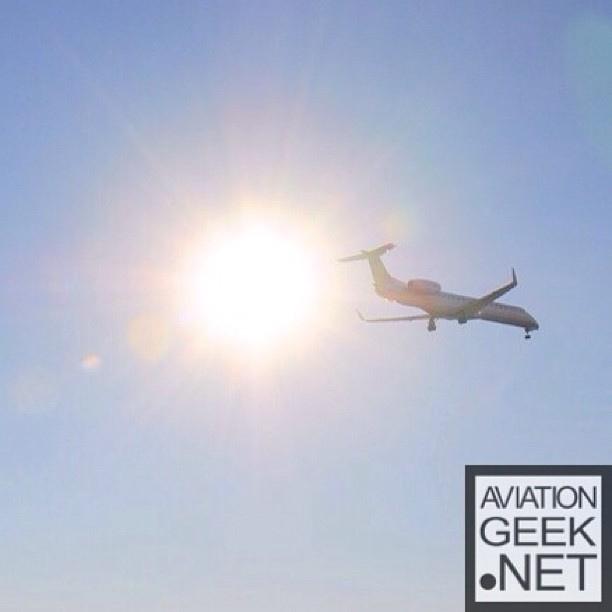Was this picture likely to have been taken at noon?
Answer briefly. Yes. What is the writing in picture?
Concise answer only. Aviation geek net. What is in the sky behind the airplane?
Short answer required. Sun. Is the sky overcast?
Short answer required. No. What is trailing from the plane?
Quick response, please. Sun. Hazy or sunny?
Keep it brief. Sunny. Could this plane be military?
Answer briefly. No. Is there a lake in the picture?
Be succinct. No. Are there clouds?
Answer briefly. No. What is shining so brightly?
Concise answer only. Sun. Is it night time?
Be succinct. No. What is in the air?
Quick response, please. Airplane. What time of day is it?
Short answer required. Noon. Who owns this photo?
Quick response, please. Aviationgeeknet. What are the weather conditions?
Write a very short answer. Sunny. Is the sun or the moon in this picture?
Concise answer only. Sun. Is the photo black and white?
Quick response, please. No. Is the weather cloudy or clear?
Write a very short answer. Clear. What is the man flying?
Be succinct. Plane. Is there a person getting out of the helicopter?
Quick response, please. No. 